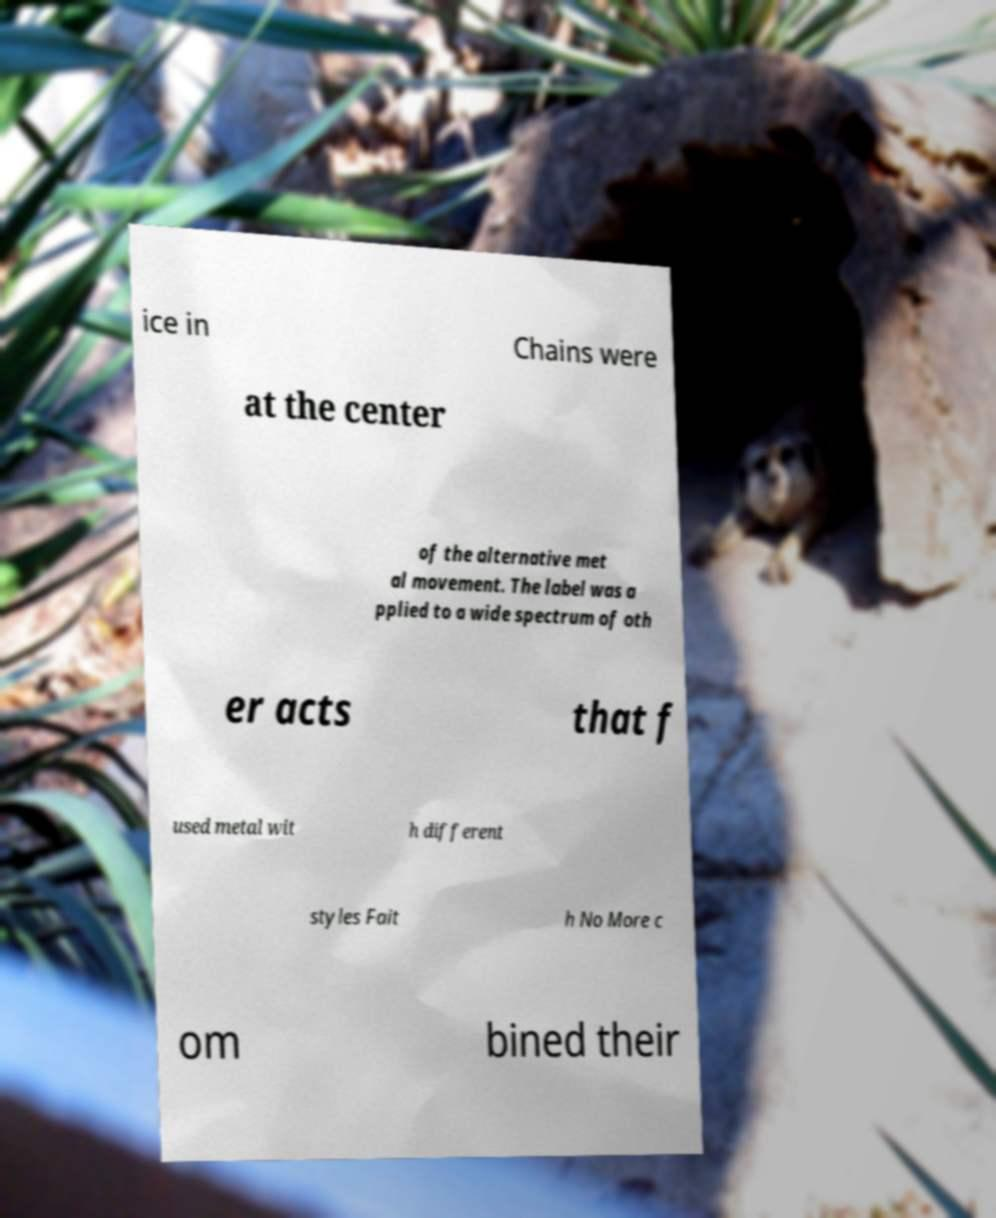Could you assist in decoding the text presented in this image and type it out clearly? ice in Chains were at the center of the alternative met al movement. The label was a pplied to a wide spectrum of oth er acts that f used metal wit h different styles Fait h No More c om bined their 